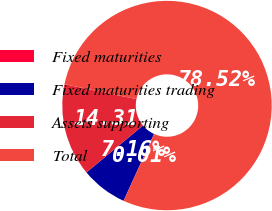Convert chart. <chart><loc_0><loc_0><loc_500><loc_500><pie_chart><fcel>Fixed maturities<fcel>Fixed maturities trading<fcel>Assets supporting<fcel>Total<nl><fcel>0.01%<fcel>7.16%<fcel>14.31%<fcel>78.52%<nl></chart> 